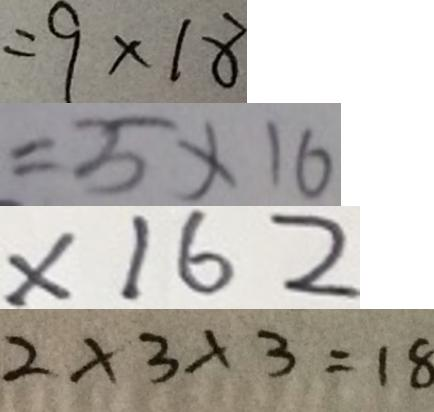Convert formula to latex. <formula><loc_0><loc_0><loc_500><loc_500>= 9 \times 1 8 
 = 5 \times 1 6 
 \times 1 6 2 
 2 \times 3 \times 3 = 1 8</formula> 